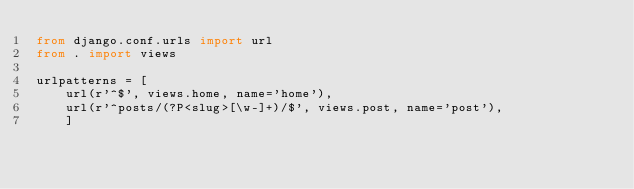<code> <loc_0><loc_0><loc_500><loc_500><_Python_>from django.conf.urls import url
from . import views

urlpatterns = [
    url(r'^$', views.home, name='home'),
    url(r'^posts/(?P<slug>[\w-]+)/$', views.post, name='post'),
    ]
</code> 